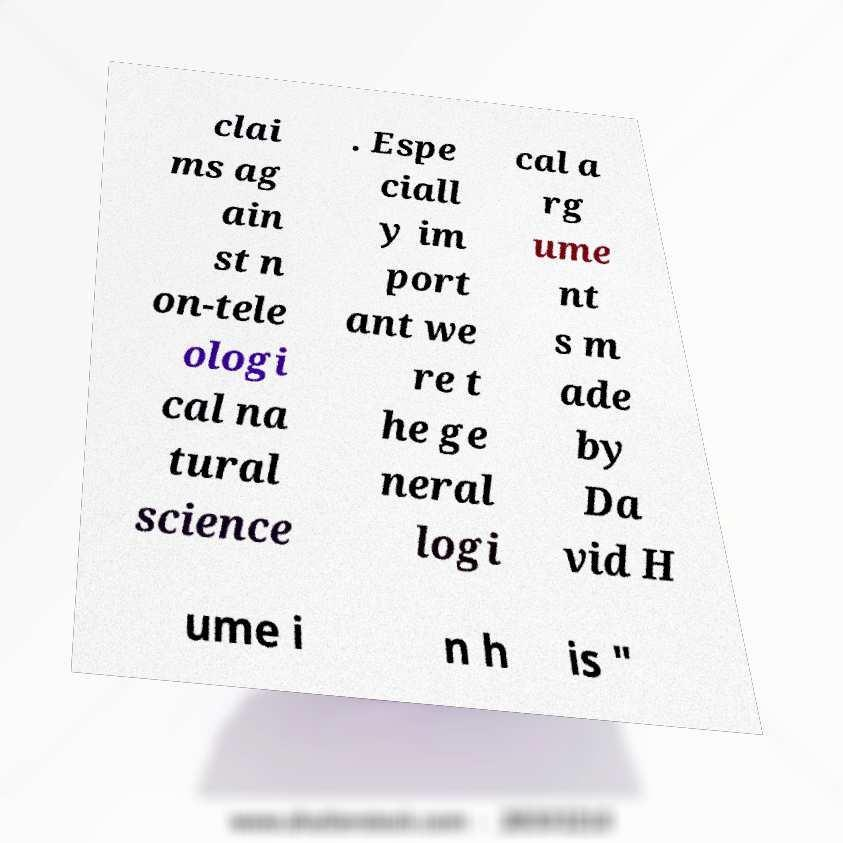There's text embedded in this image that I need extracted. Can you transcribe it verbatim? clai ms ag ain st n on-tele ologi cal na tural science . Espe ciall y im port ant we re t he ge neral logi cal a rg ume nt s m ade by Da vid H ume i n h is " 